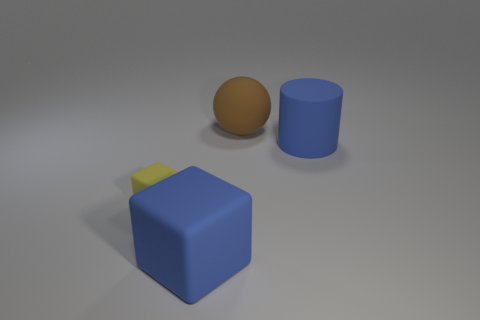There is a block that is the same color as the rubber cylinder; what is its size?
Keep it short and to the point. Large. There is a blue matte thing to the right of the large blue block; is its size the same as the yellow object to the left of the large blue cylinder?
Give a very brief answer. No. There is a yellow matte object; does it have the same size as the blue rubber object to the right of the brown object?
Offer a very short reply. No. Is the size of the matte sphere the same as the yellow cube?
Offer a terse response. No. What number of other things are the same shape as the brown matte object?
Your answer should be very brief. 0. What is the shape of the big blue rubber thing that is behind the big blue rubber block?
Give a very brief answer. Cylinder. There is a large blue thing that is left of the big brown object; is it the same shape as the small yellow matte object to the left of the brown matte sphere?
Offer a very short reply. Yes. Are there the same number of blocks that are in front of the yellow matte cube and blue metal cubes?
Make the answer very short. No. Are there any other things that are the same size as the yellow rubber cube?
Your answer should be very brief. No. What shape is the blue thing right of the rubber thing that is in front of the yellow rubber thing?
Offer a very short reply. Cylinder. 